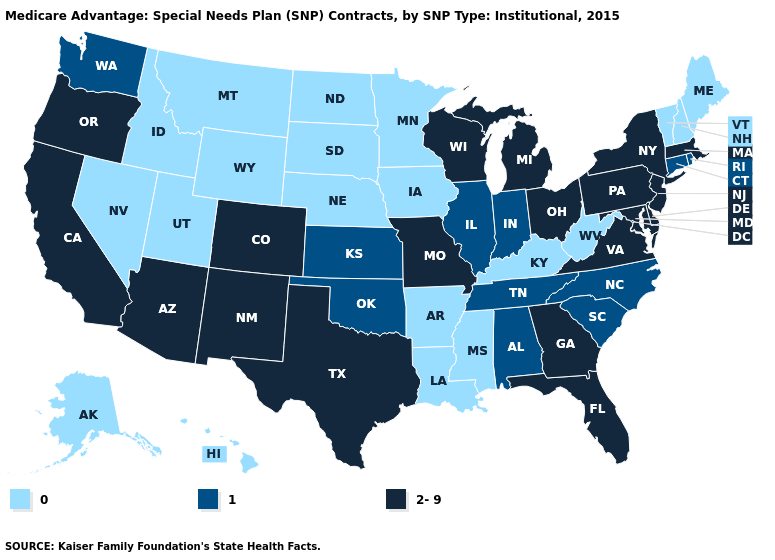Does North Carolina have a lower value than Massachusetts?
Be succinct. Yes. Among the states that border Maryland , which have the highest value?
Concise answer only. Delaware, Pennsylvania, Virginia. Name the states that have a value in the range 0?
Keep it brief. Alaska, Arkansas, Hawaii, Iowa, Idaho, Kentucky, Louisiana, Maine, Minnesota, Mississippi, Montana, North Dakota, Nebraska, New Hampshire, Nevada, South Dakota, Utah, Vermont, West Virginia, Wyoming. Name the states that have a value in the range 1?
Short answer required. Alabama, Connecticut, Illinois, Indiana, Kansas, North Carolina, Oklahoma, Rhode Island, South Carolina, Tennessee, Washington. Name the states that have a value in the range 0?
Short answer required. Alaska, Arkansas, Hawaii, Iowa, Idaho, Kentucky, Louisiana, Maine, Minnesota, Mississippi, Montana, North Dakota, Nebraska, New Hampshire, Nevada, South Dakota, Utah, Vermont, West Virginia, Wyoming. Name the states that have a value in the range 1?
Quick response, please. Alabama, Connecticut, Illinois, Indiana, Kansas, North Carolina, Oklahoma, Rhode Island, South Carolina, Tennessee, Washington. What is the lowest value in states that border Kansas?
Concise answer only. 0. Among the states that border Texas , does Louisiana have the lowest value?
Answer briefly. Yes. Does the first symbol in the legend represent the smallest category?
Short answer required. Yes. What is the lowest value in states that border Massachusetts?
Be succinct. 0. What is the value of Louisiana?
Keep it brief. 0. What is the lowest value in the USA?
Short answer required. 0. Name the states that have a value in the range 2-9?
Concise answer only. Arizona, California, Colorado, Delaware, Florida, Georgia, Massachusetts, Maryland, Michigan, Missouri, New Jersey, New Mexico, New York, Ohio, Oregon, Pennsylvania, Texas, Virginia, Wisconsin. What is the value of Minnesota?
Give a very brief answer. 0. What is the value of Missouri?
Write a very short answer. 2-9. 